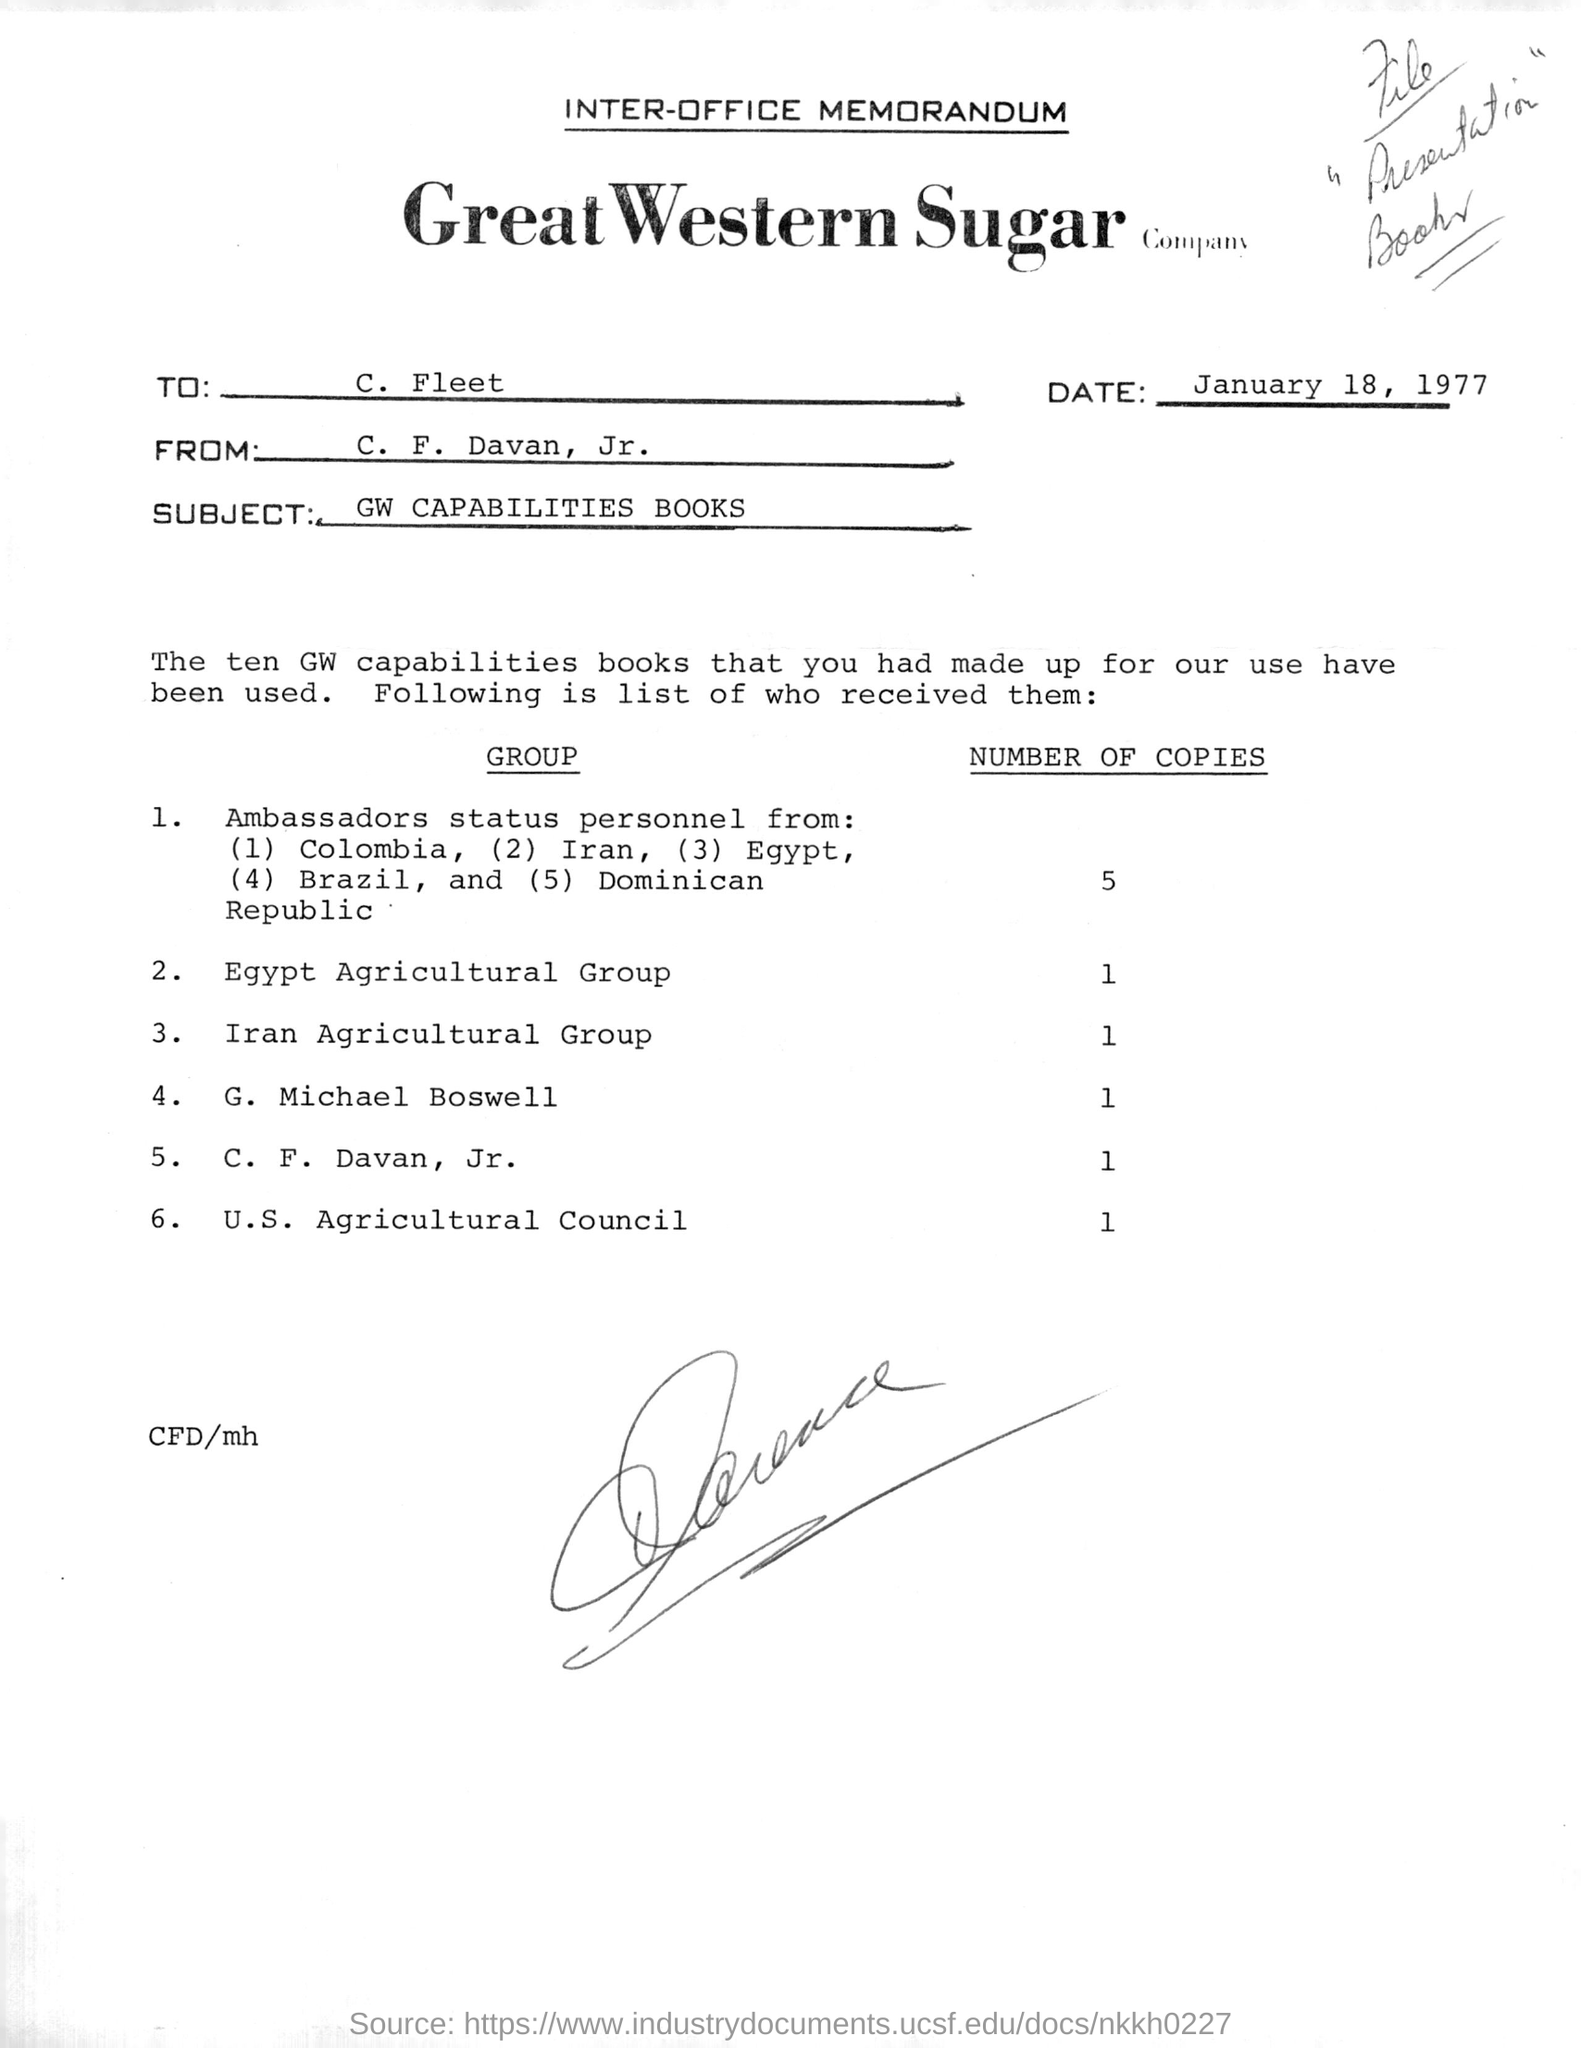What is the subject of the memorandum?
Your answer should be very brief. GW CAPABILITIES BOOKS. To Whom is this memorandum addressed to?
Your answer should be very brief. C. Fleet. What is the date in the memorandum?
Your answer should be very brief. January 18, 1977. How many books did U.S. Agricultural Council receive?
Offer a terse response. 1. How many books did G. Michael Boswell receive?
Your answer should be very brief. 1. 